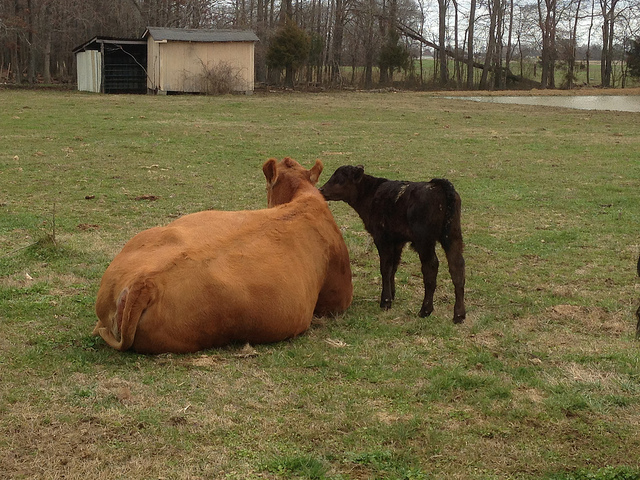<image>Are these cows curious about the people? I cannot determine if the cows are curious about the people. Is the cow ready to be milked? It is unknown if the cow is ready to be milked. Are these cows curious about the people? It is unanswerable whether these cows are curious about the people. Is the cow ready to be milked? I don't know if the cow is ready to be milked. 